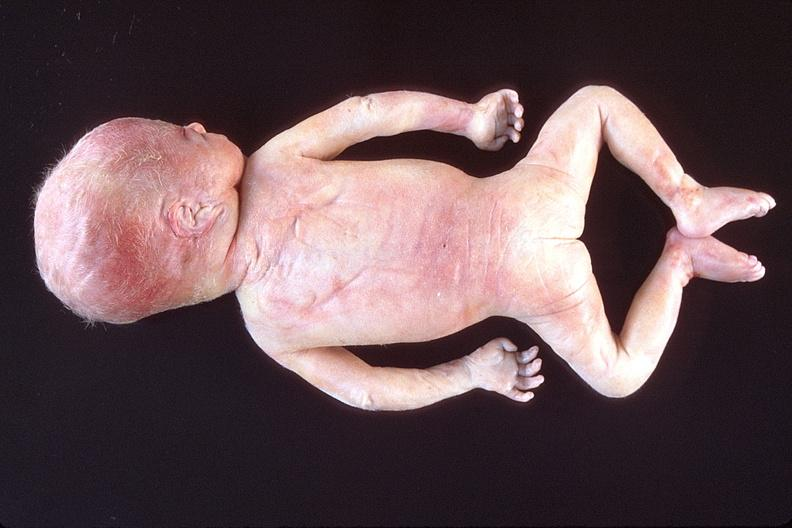does this image show hyaline membrane disease?
Answer the question using a single word or phrase. Yes 